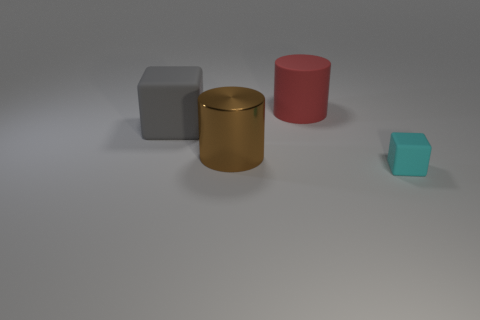Add 2 matte objects. How many objects exist? 6 Subtract all red cylinders. How many cylinders are left? 1 Subtract 0 red cubes. How many objects are left? 4 Subtract 2 cylinders. How many cylinders are left? 0 Subtract all red cubes. Subtract all gray balls. How many cubes are left? 2 Subtract all yellow cylinders. How many blue cubes are left? 0 Subtract all yellow spheres. Subtract all cyan matte blocks. How many objects are left? 3 Add 1 tiny rubber objects. How many tiny rubber objects are left? 2 Add 2 big brown things. How many big brown things exist? 3 